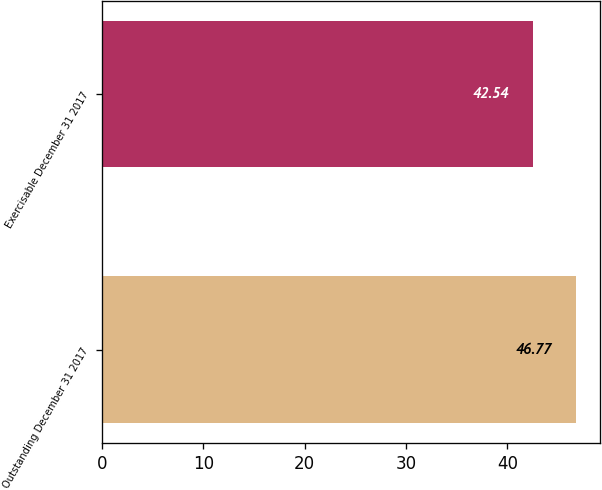<chart> <loc_0><loc_0><loc_500><loc_500><bar_chart><fcel>Outstanding December 31 2017<fcel>Exercisable December 31 2017<nl><fcel>46.77<fcel>42.54<nl></chart> 